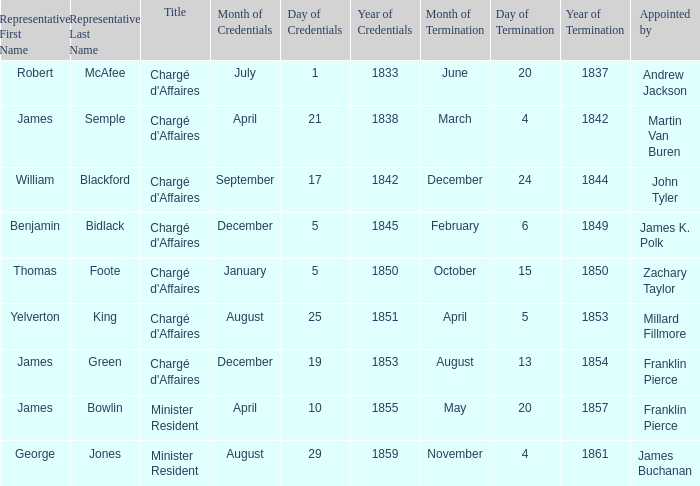Which Title has an Appointed by of Millard Fillmore? Chargé d'Affaires. 